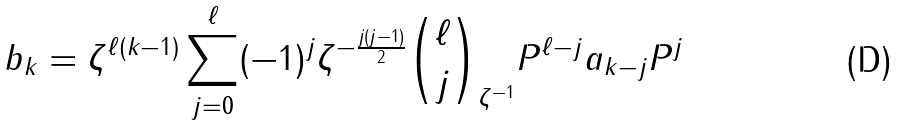<formula> <loc_0><loc_0><loc_500><loc_500>b _ { k } = \zeta ^ { \ell ( k - 1 ) } \sum _ { j = 0 } ^ { \ell } ( - 1 ) ^ { j } \zeta ^ { - \frac { j ( j - 1 ) } { 2 } } \binom { \ell } { j } _ { \zeta ^ { - 1 } } P ^ { \ell - j } a _ { k - j } P ^ { j }</formula> 